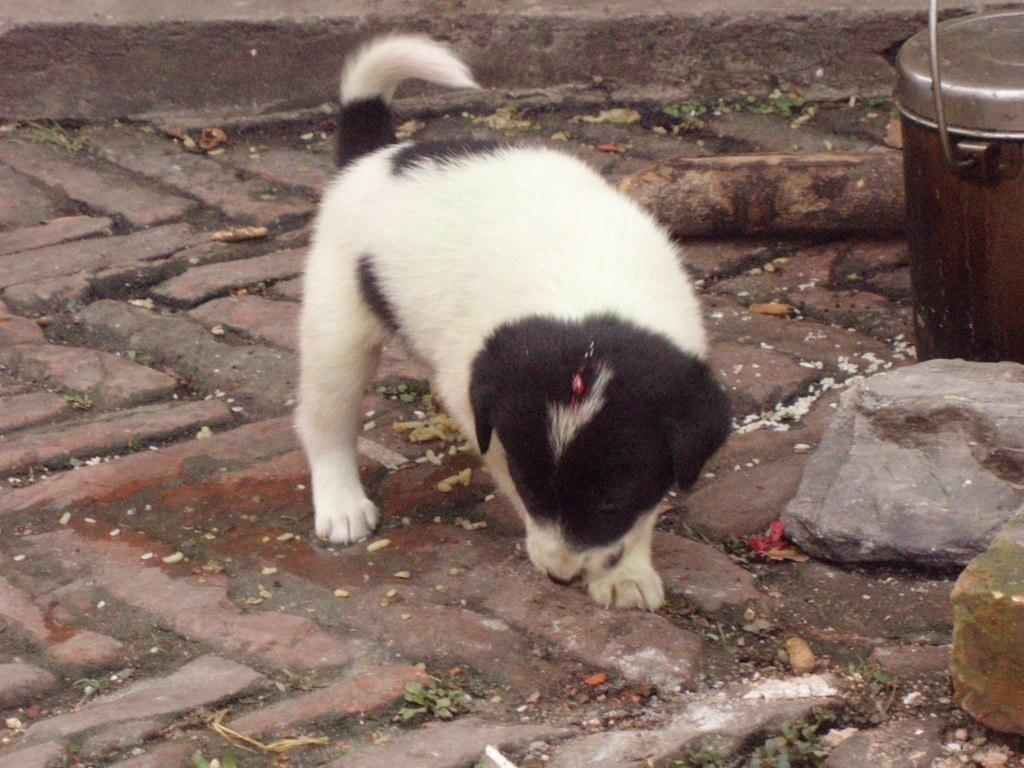What type of animal is in the image? There is a puppy in the image. What is the puppy doing in the image? The puppy is standing on the ground. What is located beside the puppy? There is a can beside the puppy. What is on the ground in the image? There are rocks on the ground in the image. What color scheme is used for the puppy in the image? The puppy is in black and white color. What direction is the puppy facing in the image? The provided facts do not mention the direction the puppy is facing, so it cannot be determined from the image. What letters are visible on the rocks in the image? There are no letters visible on the rocks in the image; only the puppy, can, and rocks are present. 